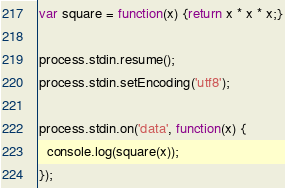Convert code to text. <code><loc_0><loc_0><loc_500><loc_500><_JavaScript_>var square = function(x) {return x * x * x;}

process.stdin.resume();
process.stdin.setEncoding('utf8');

process.stdin.on('data', function(x) {
  console.log(square(x));
});</code> 